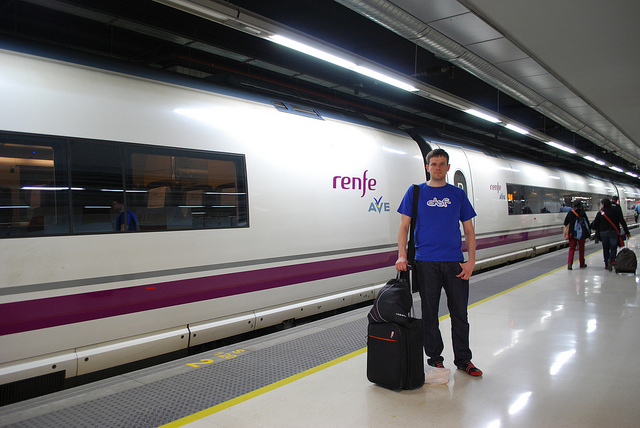Please transcribe the text information in this image. renfe AVE 2 